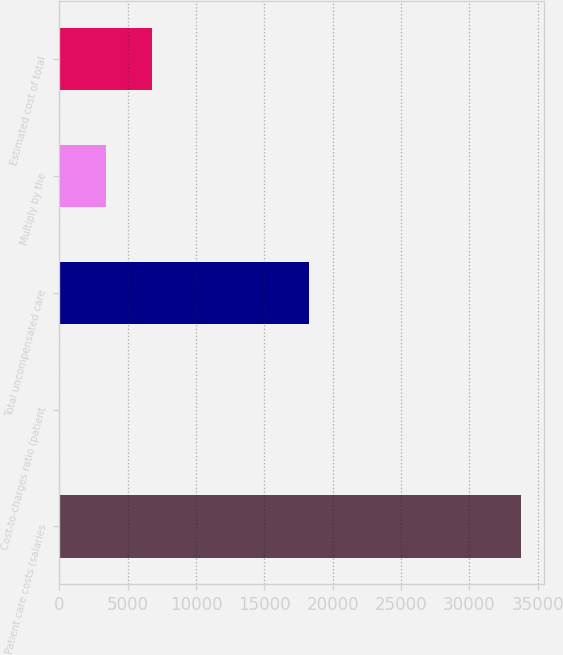Convert chart. <chart><loc_0><loc_0><loc_500><loc_500><bar_chart><fcel>Patient care costs (salaries<fcel>Cost-to-charges ratio (patient<fcel>Total uncompensated care<fcel>Multiply by the<fcel>Estimated cost of total<nl><fcel>33760<fcel>14.5<fcel>18287<fcel>3389.05<fcel>6763.6<nl></chart> 